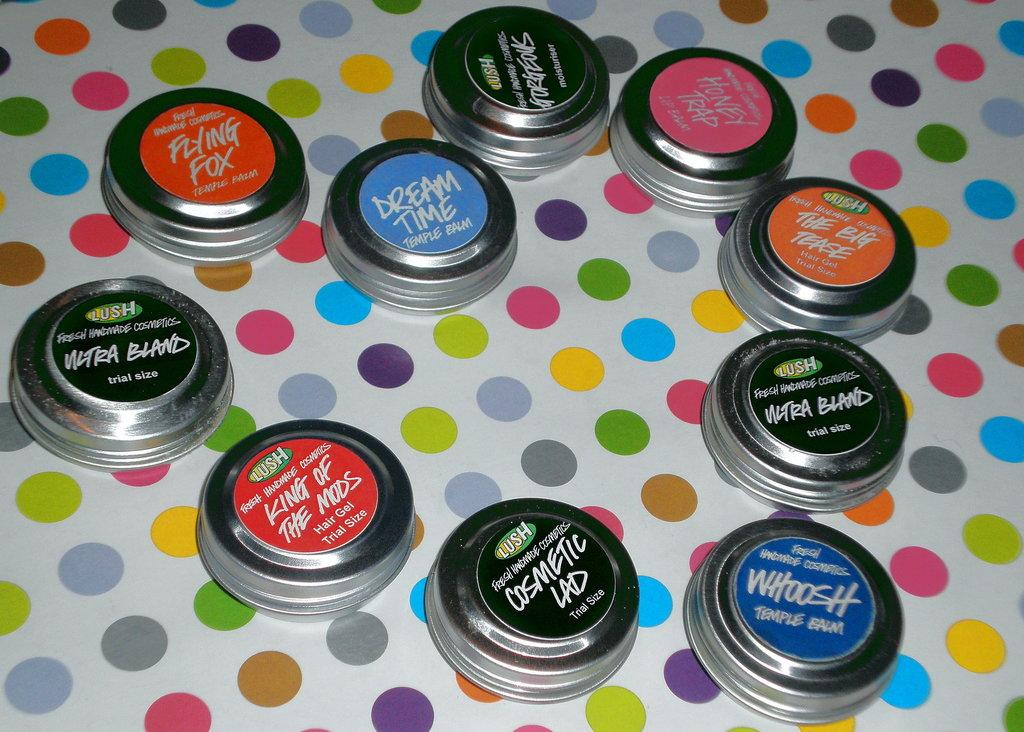How many children are in the image? There are kids in the image, but the exact number is not specified. What are the kids doing in the image? The kids are on an object, but the nature of the object is not mentioned. What type of expansion is taking place in the image? There is no mention of expansion in the image, as it only features kids on an object. 